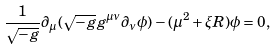Convert formula to latex. <formula><loc_0><loc_0><loc_500><loc_500>\frac { 1 } { \sqrt { - g } } \partial _ { \mu } ( \sqrt { - g } g ^ { \mu \nu } \partial _ { \nu } \phi ) - ( \mu ^ { 2 } + \xi R ) \phi = 0 ,</formula> 